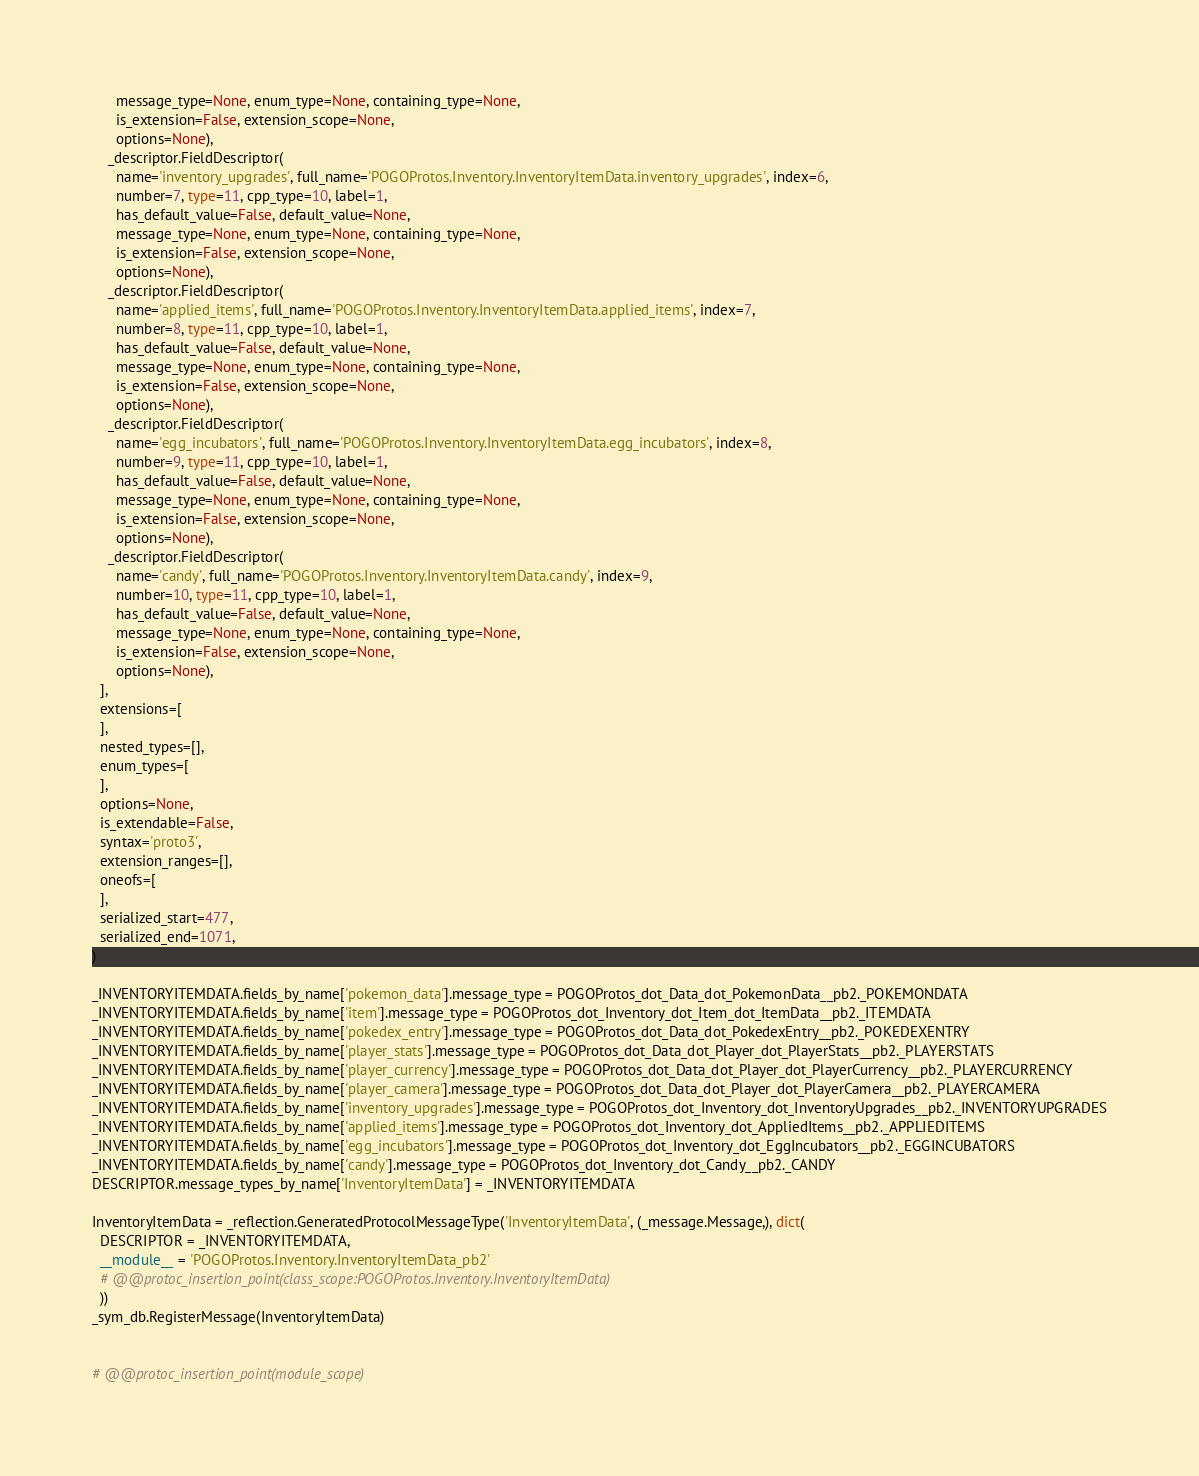Convert code to text. <code><loc_0><loc_0><loc_500><loc_500><_Python_>      message_type=None, enum_type=None, containing_type=None,
      is_extension=False, extension_scope=None,
      options=None),
    _descriptor.FieldDescriptor(
      name='inventory_upgrades', full_name='POGOProtos.Inventory.InventoryItemData.inventory_upgrades', index=6,
      number=7, type=11, cpp_type=10, label=1,
      has_default_value=False, default_value=None,
      message_type=None, enum_type=None, containing_type=None,
      is_extension=False, extension_scope=None,
      options=None),
    _descriptor.FieldDescriptor(
      name='applied_items', full_name='POGOProtos.Inventory.InventoryItemData.applied_items', index=7,
      number=8, type=11, cpp_type=10, label=1,
      has_default_value=False, default_value=None,
      message_type=None, enum_type=None, containing_type=None,
      is_extension=False, extension_scope=None,
      options=None),
    _descriptor.FieldDescriptor(
      name='egg_incubators', full_name='POGOProtos.Inventory.InventoryItemData.egg_incubators', index=8,
      number=9, type=11, cpp_type=10, label=1,
      has_default_value=False, default_value=None,
      message_type=None, enum_type=None, containing_type=None,
      is_extension=False, extension_scope=None,
      options=None),
    _descriptor.FieldDescriptor(
      name='candy', full_name='POGOProtos.Inventory.InventoryItemData.candy', index=9,
      number=10, type=11, cpp_type=10, label=1,
      has_default_value=False, default_value=None,
      message_type=None, enum_type=None, containing_type=None,
      is_extension=False, extension_scope=None,
      options=None),
  ],
  extensions=[
  ],
  nested_types=[],
  enum_types=[
  ],
  options=None,
  is_extendable=False,
  syntax='proto3',
  extension_ranges=[],
  oneofs=[
  ],
  serialized_start=477,
  serialized_end=1071,
)

_INVENTORYITEMDATA.fields_by_name['pokemon_data'].message_type = POGOProtos_dot_Data_dot_PokemonData__pb2._POKEMONDATA
_INVENTORYITEMDATA.fields_by_name['item'].message_type = POGOProtos_dot_Inventory_dot_Item_dot_ItemData__pb2._ITEMDATA
_INVENTORYITEMDATA.fields_by_name['pokedex_entry'].message_type = POGOProtos_dot_Data_dot_PokedexEntry__pb2._POKEDEXENTRY
_INVENTORYITEMDATA.fields_by_name['player_stats'].message_type = POGOProtos_dot_Data_dot_Player_dot_PlayerStats__pb2._PLAYERSTATS
_INVENTORYITEMDATA.fields_by_name['player_currency'].message_type = POGOProtos_dot_Data_dot_Player_dot_PlayerCurrency__pb2._PLAYERCURRENCY
_INVENTORYITEMDATA.fields_by_name['player_camera'].message_type = POGOProtos_dot_Data_dot_Player_dot_PlayerCamera__pb2._PLAYERCAMERA
_INVENTORYITEMDATA.fields_by_name['inventory_upgrades'].message_type = POGOProtos_dot_Inventory_dot_InventoryUpgrades__pb2._INVENTORYUPGRADES
_INVENTORYITEMDATA.fields_by_name['applied_items'].message_type = POGOProtos_dot_Inventory_dot_AppliedItems__pb2._APPLIEDITEMS
_INVENTORYITEMDATA.fields_by_name['egg_incubators'].message_type = POGOProtos_dot_Inventory_dot_EggIncubators__pb2._EGGINCUBATORS
_INVENTORYITEMDATA.fields_by_name['candy'].message_type = POGOProtos_dot_Inventory_dot_Candy__pb2._CANDY
DESCRIPTOR.message_types_by_name['InventoryItemData'] = _INVENTORYITEMDATA

InventoryItemData = _reflection.GeneratedProtocolMessageType('InventoryItemData', (_message.Message,), dict(
  DESCRIPTOR = _INVENTORYITEMDATA,
  __module__ = 'POGOProtos.Inventory.InventoryItemData_pb2'
  # @@protoc_insertion_point(class_scope:POGOProtos.Inventory.InventoryItemData)
  ))
_sym_db.RegisterMessage(InventoryItemData)


# @@protoc_insertion_point(module_scope)
</code> 